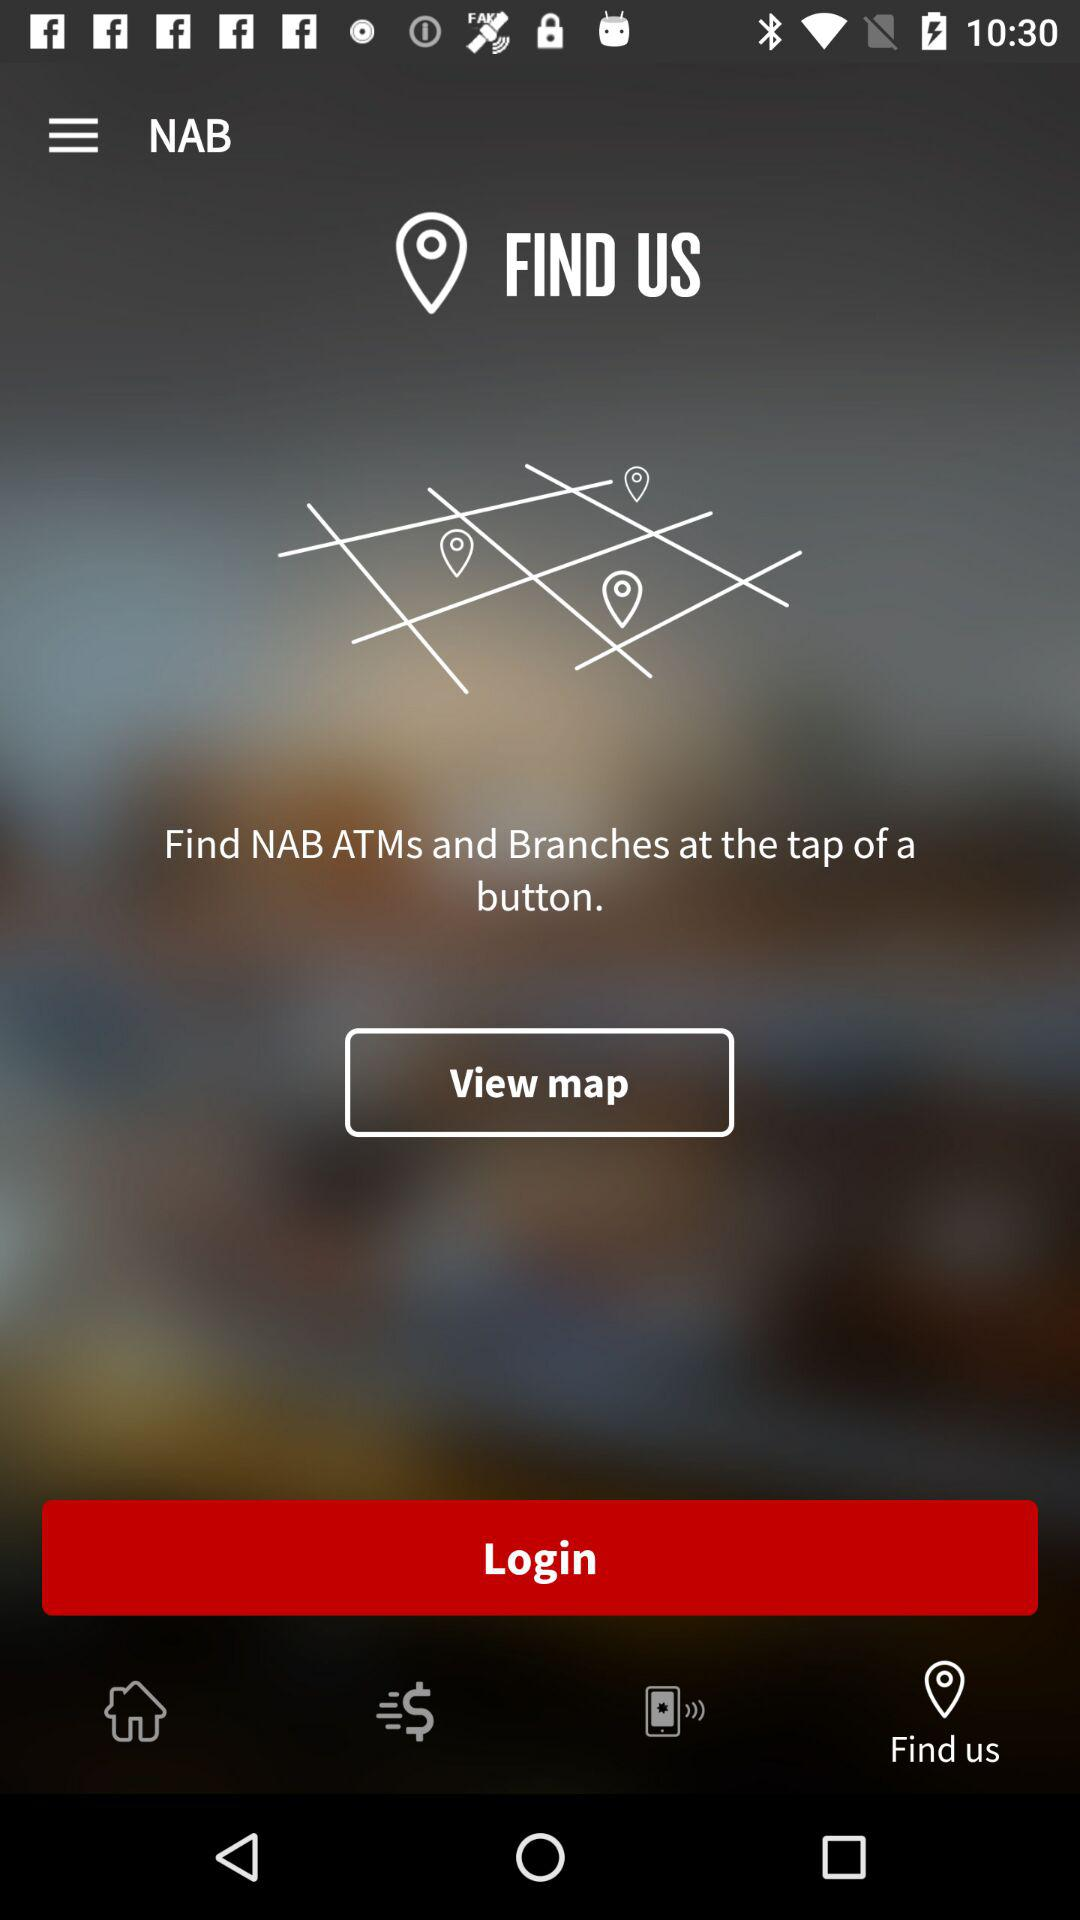What is the selected tab? The selected tab is "Find us". 